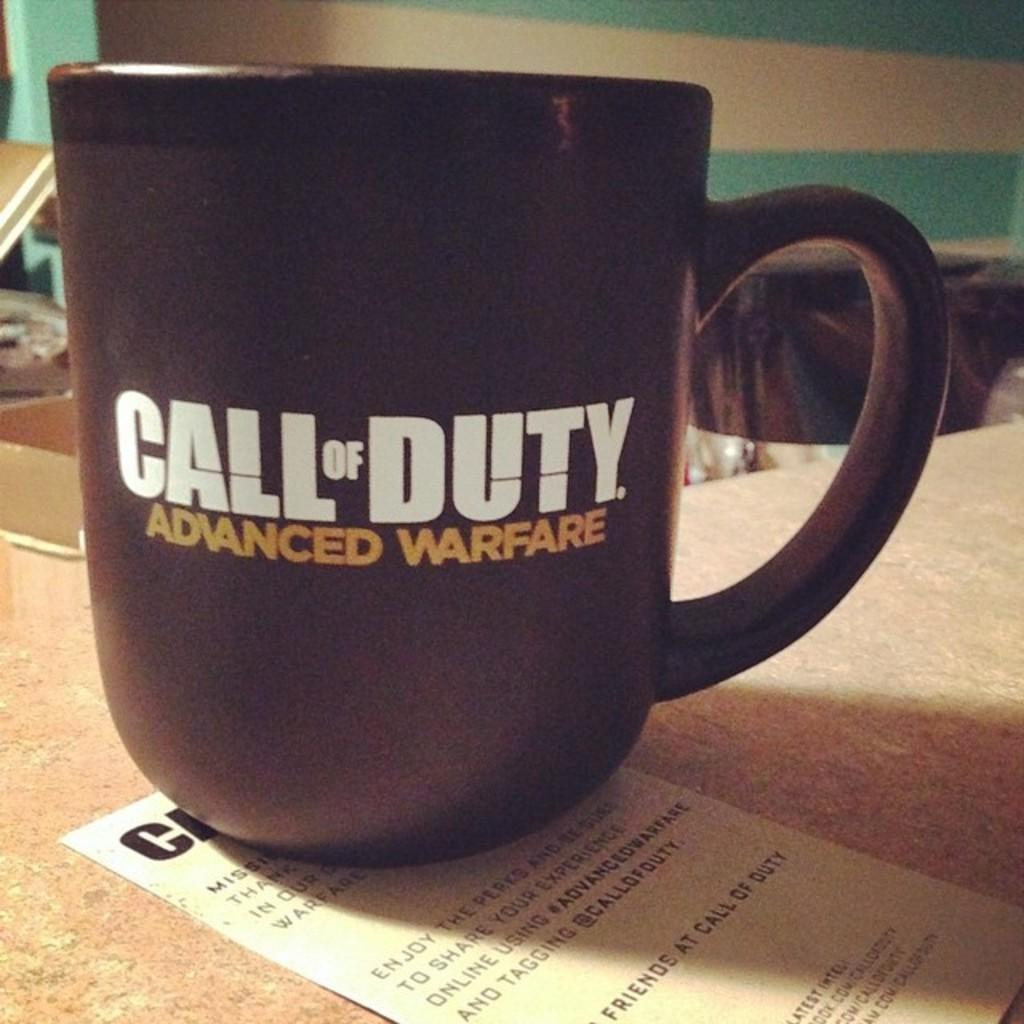<image>
Give a short and clear explanation of the subsequent image. A Call of Duty Advanced Warfare mug sits on top of a piece of paper. 